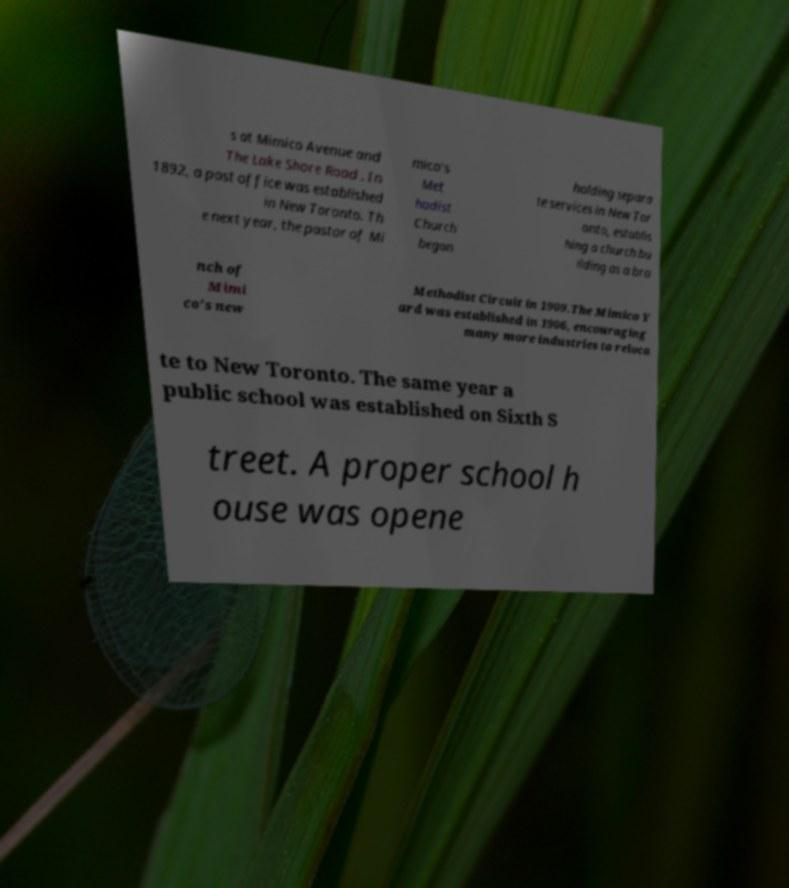Please read and relay the text visible in this image. What does it say? s at Mimico Avenue and The Lake Shore Road . In 1892, a post office was established in New Toronto. Th e next year, the pastor of Mi mico's Met hodist Church began holding separa te services in New Tor onto, establis hing a church bu ilding as a bra nch of Mimi co's new Methodist Circuit in 1909.The Mimico Y ard was established in 1906, encouraging many more industries to reloca te to New Toronto. The same year a public school was established on Sixth S treet. A proper school h ouse was opene 